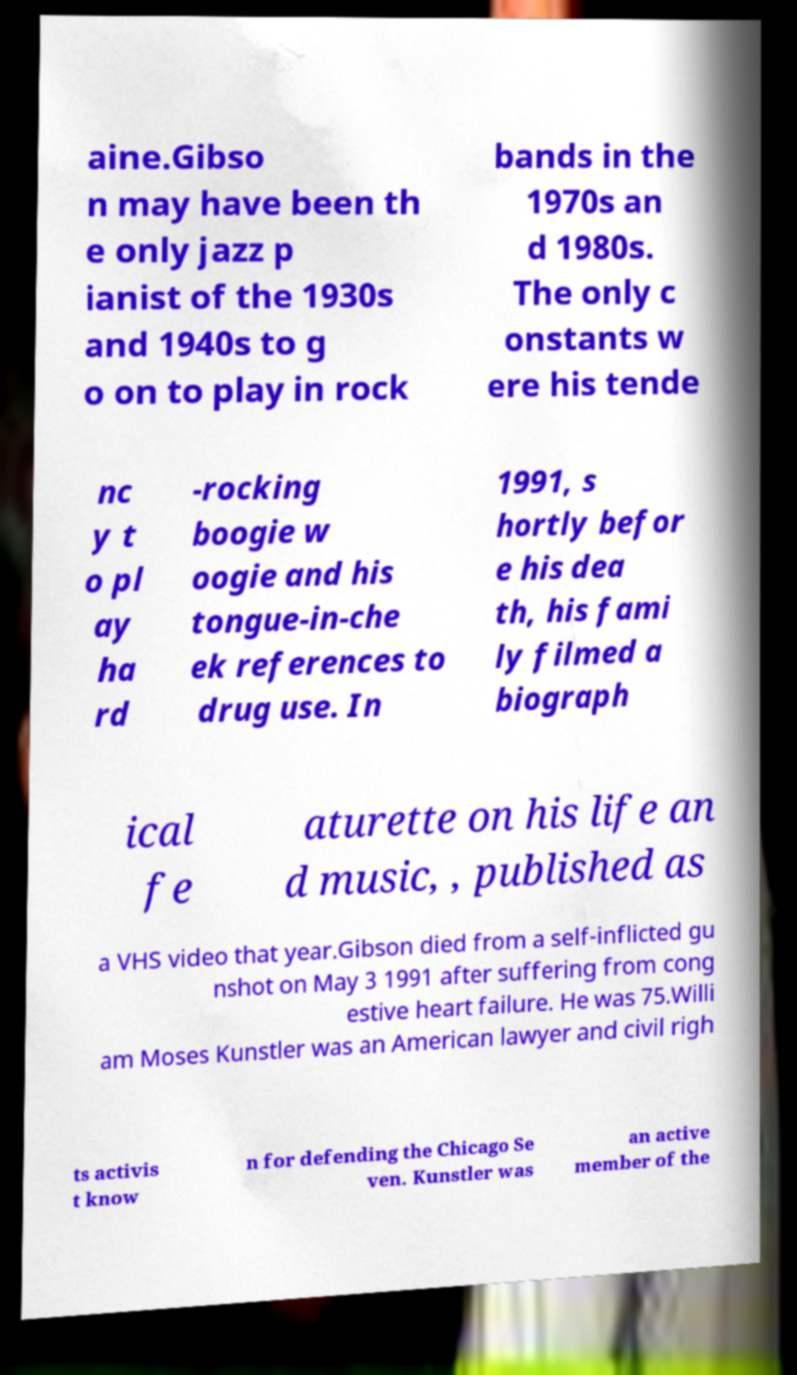Can you accurately transcribe the text from the provided image for me? aine.Gibso n may have been th e only jazz p ianist of the 1930s and 1940s to g o on to play in rock bands in the 1970s an d 1980s. The only c onstants w ere his tende nc y t o pl ay ha rd -rocking boogie w oogie and his tongue-in-che ek references to drug use. In 1991, s hortly befor e his dea th, his fami ly filmed a biograph ical fe aturette on his life an d music, , published as a VHS video that year.Gibson died from a self-inflicted gu nshot on May 3 1991 after suffering from cong estive heart failure. He was 75.Willi am Moses Kunstler was an American lawyer and civil righ ts activis t know n for defending the Chicago Se ven. Kunstler was an active member of the 